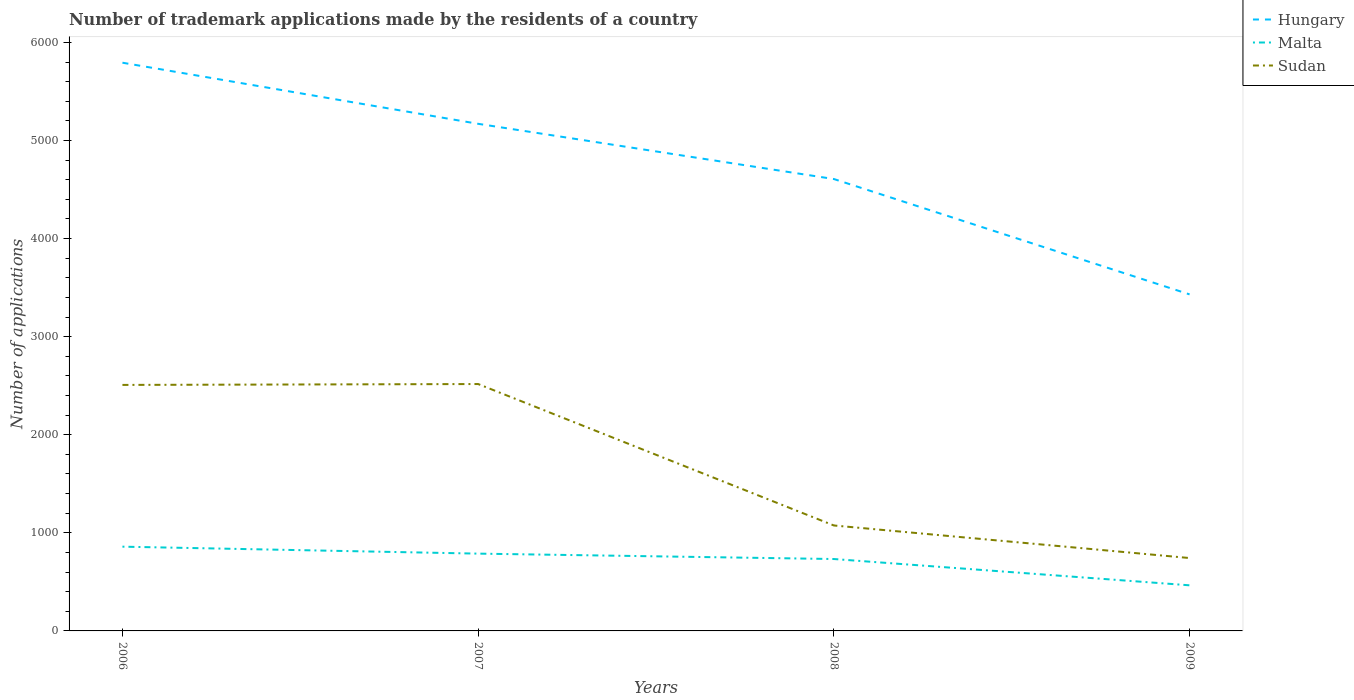How many different coloured lines are there?
Give a very brief answer. 3. Does the line corresponding to Sudan intersect with the line corresponding to Malta?
Your response must be concise. No. Across all years, what is the maximum number of trademark applications made by the residents in Hungary?
Offer a terse response. 3431. What is the total number of trademark applications made by the residents in Sudan in the graph?
Offer a very short reply. 1433. What is the difference between the highest and the second highest number of trademark applications made by the residents in Malta?
Your answer should be very brief. 394. What is the difference between the highest and the lowest number of trademark applications made by the residents in Hungary?
Make the answer very short. 2. Is the number of trademark applications made by the residents in Hungary strictly greater than the number of trademark applications made by the residents in Malta over the years?
Give a very brief answer. No. How many lines are there?
Your answer should be very brief. 3. How many years are there in the graph?
Offer a very short reply. 4. Does the graph contain any zero values?
Give a very brief answer. No. Does the graph contain grids?
Offer a very short reply. No. How many legend labels are there?
Offer a terse response. 3. What is the title of the graph?
Ensure brevity in your answer.  Number of trademark applications made by the residents of a country. What is the label or title of the X-axis?
Your response must be concise. Years. What is the label or title of the Y-axis?
Provide a succinct answer. Number of applications. What is the Number of applications in Hungary in 2006?
Your answer should be very brief. 5793. What is the Number of applications in Malta in 2006?
Provide a succinct answer. 859. What is the Number of applications of Sudan in 2006?
Keep it short and to the point. 2508. What is the Number of applications in Hungary in 2007?
Offer a very short reply. 5170. What is the Number of applications in Malta in 2007?
Give a very brief answer. 788. What is the Number of applications in Sudan in 2007?
Give a very brief answer. 2517. What is the Number of applications of Hungary in 2008?
Provide a short and direct response. 4607. What is the Number of applications in Malta in 2008?
Offer a terse response. 733. What is the Number of applications in Sudan in 2008?
Your response must be concise. 1075. What is the Number of applications of Hungary in 2009?
Keep it short and to the point. 3431. What is the Number of applications of Malta in 2009?
Offer a terse response. 465. What is the Number of applications in Sudan in 2009?
Keep it short and to the point. 743. Across all years, what is the maximum Number of applications of Hungary?
Make the answer very short. 5793. Across all years, what is the maximum Number of applications in Malta?
Ensure brevity in your answer.  859. Across all years, what is the maximum Number of applications of Sudan?
Keep it short and to the point. 2517. Across all years, what is the minimum Number of applications in Hungary?
Make the answer very short. 3431. Across all years, what is the minimum Number of applications of Malta?
Ensure brevity in your answer.  465. Across all years, what is the minimum Number of applications in Sudan?
Offer a terse response. 743. What is the total Number of applications in Hungary in the graph?
Give a very brief answer. 1.90e+04. What is the total Number of applications in Malta in the graph?
Keep it short and to the point. 2845. What is the total Number of applications of Sudan in the graph?
Ensure brevity in your answer.  6843. What is the difference between the Number of applications in Hungary in 2006 and that in 2007?
Your answer should be very brief. 623. What is the difference between the Number of applications of Malta in 2006 and that in 2007?
Provide a succinct answer. 71. What is the difference between the Number of applications in Sudan in 2006 and that in 2007?
Offer a terse response. -9. What is the difference between the Number of applications of Hungary in 2006 and that in 2008?
Make the answer very short. 1186. What is the difference between the Number of applications in Malta in 2006 and that in 2008?
Provide a succinct answer. 126. What is the difference between the Number of applications of Sudan in 2006 and that in 2008?
Offer a very short reply. 1433. What is the difference between the Number of applications of Hungary in 2006 and that in 2009?
Your answer should be compact. 2362. What is the difference between the Number of applications in Malta in 2006 and that in 2009?
Ensure brevity in your answer.  394. What is the difference between the Number of applications of Sudan in 2006 and that in 2009?
Provide a succinct answer. 1765. What is the difference between the Number of applications of Hungary in 2007 and that in 2008?
Make the answer very short. 563. What is the difference between the Number of applications of Malta in 2007 and that in 2008?
Your response must be concise. 55. What is the difference between the Number of applications of Sudan in 2007 and that in 2008?
Give a very brief answer. 1442. What is the difference between the Number of applications of Hungary in 2007 and that in 2009?
Your answer should be very brief. 1739. What is the difference between the Number of applications in Malta in 2007 and that in 2009?
Keep it short and to the point. 323. What is the difference between the Number of applications in Sudan in 2007 and that in 2009?
Ensure brevity in your answer.  1774. What is the difference between the Number of applications in Hungary in 2008 and that in 2009?
Your answer should be very brief. 1176. What is the difference between the Number of applications of Malta in 2008 and that in 2009?
Offer a terse response. 268. What is the difference between the Number of applications of Sudan in 2008 and that in 2009?
Ensure brevity in your answer.  332. What is the difference between the Number of applications in Hungary in 2006 and the Number of applications in Malta in 2007?
Ensure brevity in your answer.  5005. What is the difference between the Number of applications in Hungary in 2006 and the Number of applications in Sudan in 2007?
Make the answer very short. 3276. What is the difference between the Number of applications in Malta in 2006 and the Number of applications in Sudan in 2007?
Offer a terse response. -1658. What is the difference between the Number of applications of Hungary in 2006 and the Number of applications of Malta in 2008?
Your response must be concise. 5060. What is the difference between the Number of applications of Hungary in 2006 and the Number of applications of Sudan in 2008?
Offer a very short reply. 4718. What is the difference between the Number of applications in Malta in 2006 and the Number of applications in Sudan in 2008?
Your response must be concise. -216. What is the difference between the Number of applications of Hungary in 2006 and the Number of applications of Malta in 2009?
Your answer should be very brief. 5328. What is the difference between the Number of applications in Hungary in 2006 and the Number of applications in Sudan in 2009?
Your response must be concise. 5050. What is the difference between the Number of applications in Malta in 2006 and the Number of applications in Sudan in 2009?
Offer a very short reply. 116. What is the difference between the Number of applications of Hungary in 2007 and the Number of applications of Malta in 2008?
Ensure brevity in your answer.  4437. What is the difference between the Number of applications in Hungary in 2007 and the Number of applications in Sudan in 2008?
Offer a terse response. 4095. What is the difference between the Number of applications in Malta in 2007 and the Number of applications in Sudan in 2008?
Offer a terse response. -287. What is the difference between the Number of applications of Hungary in 2007 and the Number of applications of Malta in 2009?
Provide a short and direct response. 4705. What is the difference between the Number of applications in Hungary in 2007 and the Number of applications in Sudan in 2009?
Ensure brevity in your answer.  4427. What is the difference between the Number of applications of Hungary in 2008 and the Number of applications of Malta in 2009?
Provide a succinct answer. 4142. What is the difference between the Number of applications of Hungary in 2008 and the Number of applications of Sudan in 2009?
Offer a very short reply. 3864. What is the difference between the Number of applications in Malta in 2008 and the Number of applications in Sudan in 2009?
Your response must be concise. -10. What is the average Number of applications in Hungary per year?
Make the answer very short. 4750.25. What is the average Number of applications in Malta per year?
Your answer should be compact. 711.25. What is the average Number of applications of Sudan per year?
Ensure brevity in your answer.  1710.75. In the year 2006, what is the difference between the Number of applications in Hungary and Number of applications in Malta?
Offer a terse response. 4934. In the year 2006, what is the difference between the Number of applications in Hungary and Number of applications in Sudan?
Provide a succinct answer. 3285. In the year 2006, what is the difference between the Number of applications in Malta and Number of applications in Sudan?
Provide a succinct answer. -1649. In the year 2007, what is the difference between the Number of applications of Hungary and Number of applications of Malta?
Provide a succinct answer. 4382. In the year 2007, what is the difference between the Number of applications in Hungary and Number of applications in Sudan?
Keep it short and to the point. 2653. In the year 2007, what is the difference between the Number of applications of Malta and Number of applications of Sudan?
Ensure brevity in your answer.  -1729. In the year 2008, what is the difference between the Number of applications in Hungary and Number of applications in Malta?
Provide a short and direct response. 3874. In the year 2008, what is the difference between the Number of applications in Hungary and Number of applications in Sudan?
Provide a short and direct response. 3532. In the year 2008, what is the difference between the Number of applications in Malta and Number of applications in Sudan?
Provide a succinct answer. -342. In the year 2009, what is the difference between the Number of applications of Hungary and Number of applications of Malta?
Make the answer very short. 2966. In the year 2009, what is the difference between the Number of applications of Hungary and Number of applications of Sudan?
Your answer should be compact. 2688. In the year 2009, what is the difference between the Number of applications in Malta and Number of applications in Sudan?
Make the answer very short. -278. What is the ratio of the Number of applications of Hungary in 2006 to that in 2007?
Your answer should be compact. 1.12. What is the ratio of the Number of applications in Malta in 2006 to that in 2007?
Keep it short and to the point. 1.09. What is the ratio of the Number of applications in Hungary in 2006 to that in 2008?
Keep it short and to the point. 1.26. What is the ratio of the Number of applications of Malta in 2006 to that in 2008?
Keep it short and to the point. 1.17. What is the ratio of the Number of applications of Sudan in 2006 to that in 2008?
Provide a succinct answer. 2.33. What is the ratio of the Number of applications of Hungary in 2006 to that in 2009?
Provide a short and direct response. 1.69. What is the ratio of the Number of applications in Malta in 2006 to that in 2009?
Offer a very short reply. 1.85. What is the ratio of the Number of applications in Sudan in 2006 to that in 2009?
Your answer should be compact. 3.38. What is the ratio of the Number of applications in Hungary in 2007 to that in 2008?
Offer a very short reply. 1.12. What is the ratio of the Number of applications in Malta in 2007 to that in 2008?
Give a very brief answer. 1.07. What is the ratio of the Number of applications in Sudan in 2007 to that in 2008?
Offer a very short reply. 2.34. What is the ratio of the Number of applications in Hungary in 2007 to that in 2009?
Keep it short and to the point. 1.51. What is the ratio of the Number of applications of Malta in 2007 to that in 2009?
Make the answer very short. 1.69. What is the ratio of the Number of applications in Sudan in 2007 to that in 2009?
Ensure brevity in your answer.  3.39. What is the ratio of the Number of applications in Hungary in 2008 to that in 2009?
Provide a succinct answer. 1.34. What is the ratio of the Number of applications of Malta in 2008 to that in 2009?
Offer a terse response. 1.58. What is the ratio of the Number of applications of Sudan in 2008 to that in 2009?
Provide a short and direct response. 1.45. What is the difference between the highest and the second highest Number of applications of Hungary?
Offer a very short reply. 623. What is the difference between the highest and the second highest Number of applications of Sudan?
Give a very brief answer. 9. What is the difference between the highest and the lowest Number of applications in Hungary?
Ensure brevity in your answer.  2362. What is the difference between the highest and the lowest Number of applications of Malta?
Ensure brevity in your answer.  394. What is the difference between the highest and the lowest Number of applications of Sudan?
Make the answer very short. 1774. 